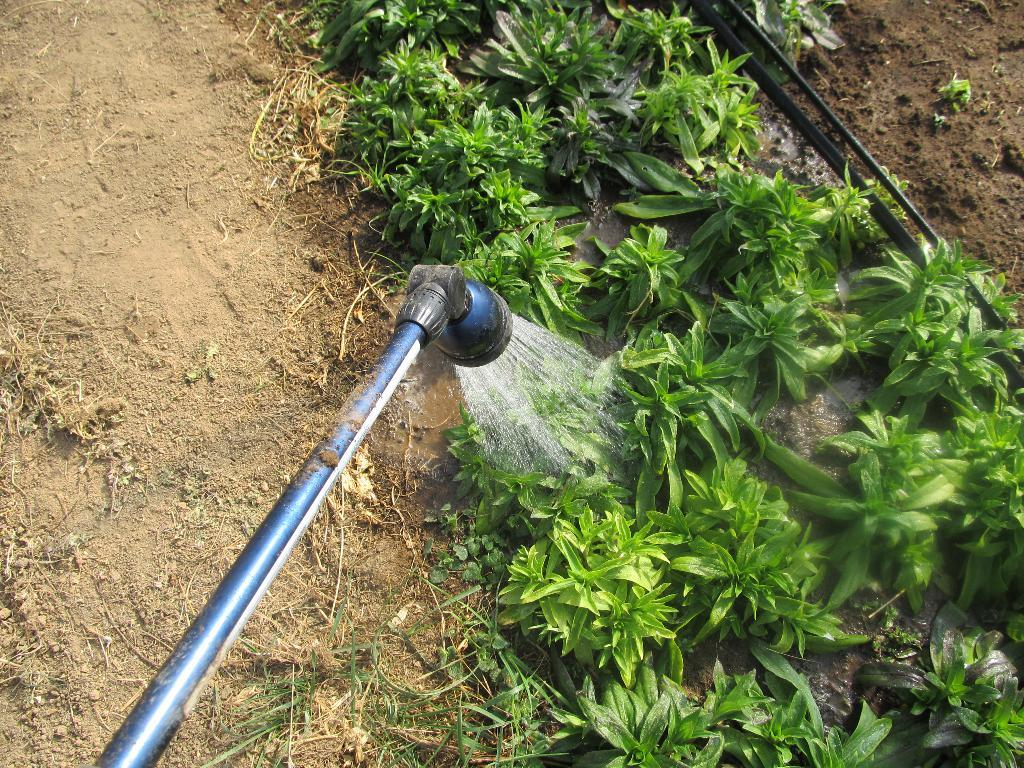What type of vegetation can be seen in the image? There are plants and grass visible in the image. What else is present in the image besides vegetation? There is an unspecified object and water visible in the image. Can you describe the object on the ground? The object on the ground is a gardening tool. What might be the purpose of the gardening tool? The gardening tool is likely used for maintaining the plants and grass in the image. What can be inferred about the time of day when the image was taken? The image was likely taken during the day, as there is sufficient light to see the details clearly. What type of news can be seen on the plants in the image? There is no news present in the image; it features plants, grass, an unspecified object, water, and a gardening tool. What type of quartz can be seen in the image? There is no quartz present in the image. 